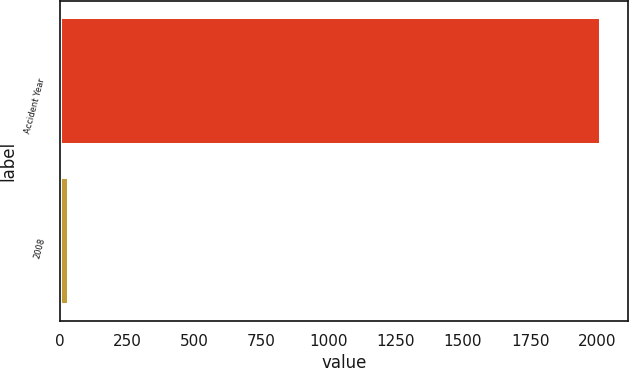<chart> <loc_0><loc_0><loc_500><loc_500><bar_chart><fcel>Accident Year<fcel>2008<nl><fcel>2013<fcel>34<nl></chart> 